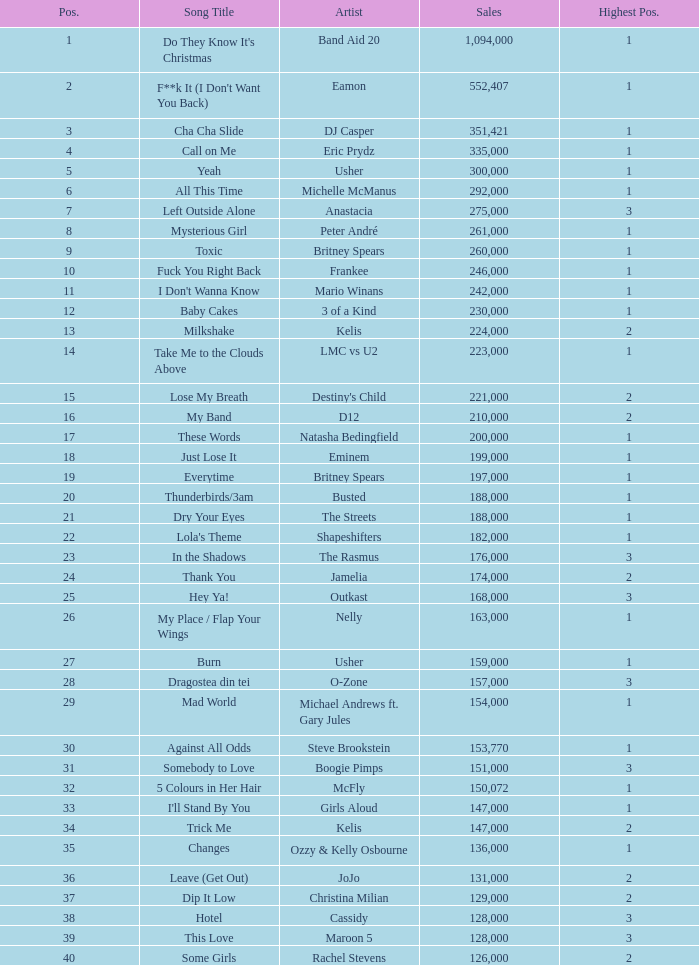What is the most sales by a song with a position higher than 3? None. 